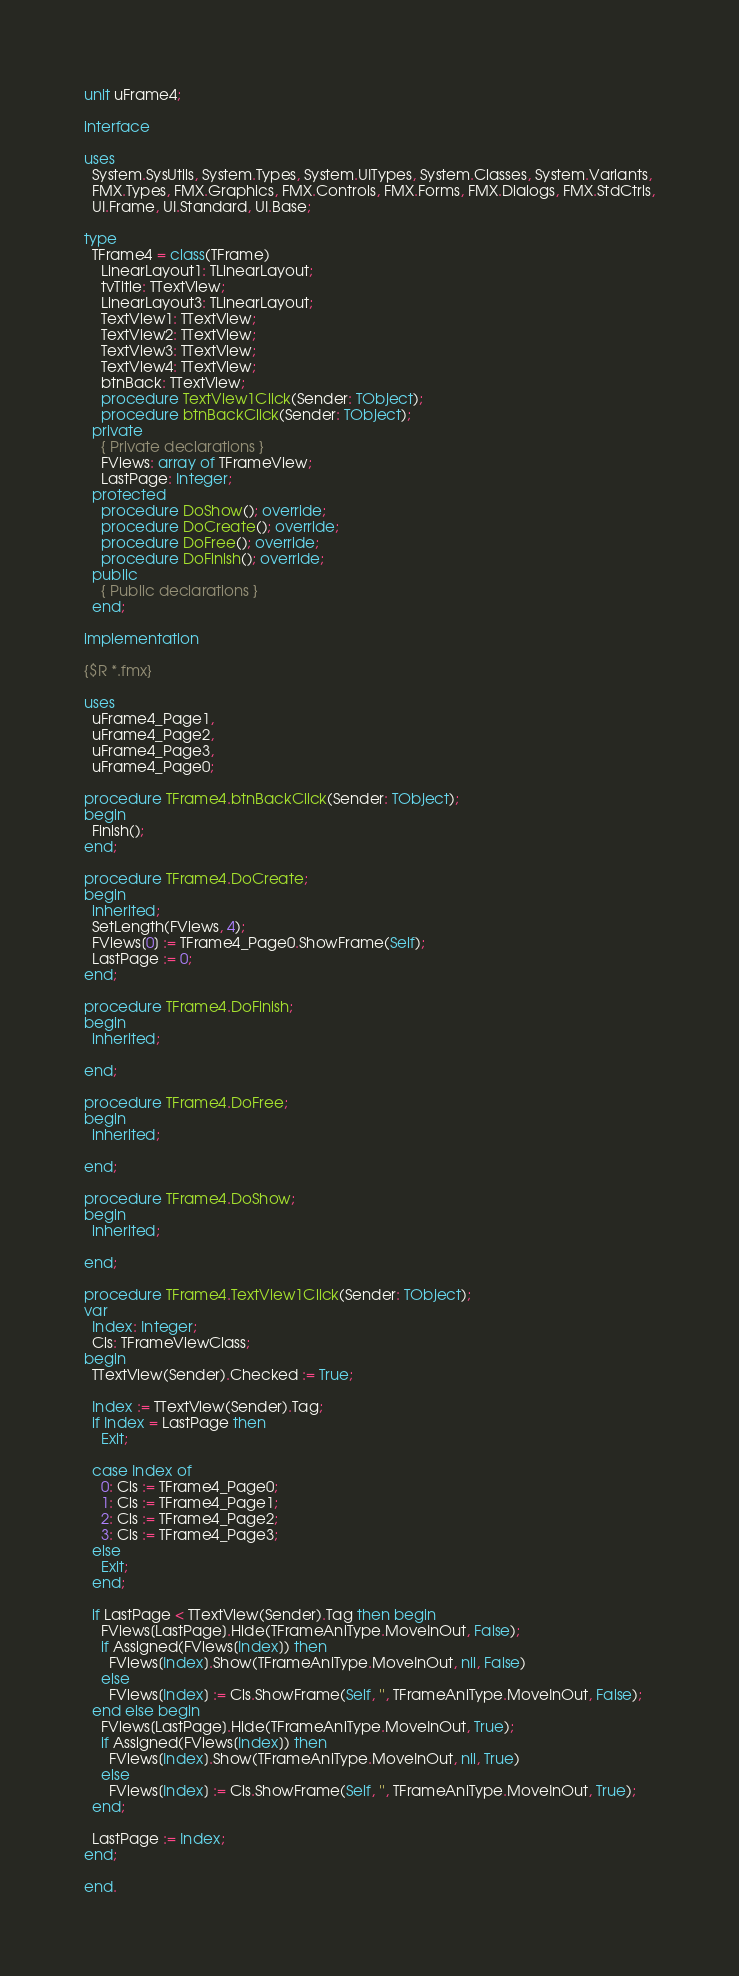Convert code to text. <code><loc_0><loc_0><loc_500><loc_500><_Pascal_>unit uFrame4;

interface

uses
  System.SysUtils, System.Types, System.UITypes, System.Classes, System.Variants,
  FMX.Types, FMX.Graphics, FMX.Controls, FMX.Forms, FMX.Dialogs, FMX.StdCtrls,
  UI.Frame, UI.Standard, UI.Base;

type
  TFrame4 = class(TFrame)
    LinearLayout1: TLinearLayout;
    tvTitle: TTextView;
    LinearLayout3: TLinearLayout;
    TextView1: TTextView;
    TextView2: TTextView;
    TextView3: TTextView;
    TextView4: TTextView;
    btnBack: TTextView;
    procedure TextView1Click(Sender: TObject);
    procedure btnBackClick(Sender: TObject);
  private
    { Private declarations }
    FViews: array of TFrameView;
    LastPage: Integer;
  protected
    procedure DoShow(); override;
    procedure DoCreate(); override;
    procedure DoFree(); override;
    procedure DoFinish(); override;
  public
    { Public declarations }
  end;

implementation

{$R *.fmx}

uses
  uFrame4_Page1,
  uFrame4_Page2,
  uFrame4_Page3,
  uFrame4_Page0;

procedure TFrame4.btnBackClick(Sender: TObject);
begin
  Finish();
end;

procedure TFrame4.DoCreate;
begin
  inherited;
  SetLength(FViews, 4);
  FViews[0] := TFrame4_Page0.ShowFrame(Self);
  LastPage := 0;
end;

procedure TFrame4.DoFinish;
begin
  inherited;

end;

procedure TFrame4.DoFree;
begin
  inherited;

end;

procedure TFrame4.DoShow;
begin
  inherited;

end;

procedure TFrame4.TextView1Click(Sender: TObject);
var
  Index: Integer;
  Cls: TFrameViewClass;
begin
  TTextView(Sender).Checked := True;

  Index := TTextView(Sender).Tag;
  if Index = LastPage then
    Exit;

  case Index of
    0: Cls := TFrame4_Page0;
    1: Cls := TFrame4_Page1;
    2: Cls := TFrame4_Page2;
    3: Cls := TFrame4_Page3;
  else
    Exit;
  end;

  if LastPage < TTextView(Sender).Tag then begin
    FViews[LastPage].Hide(TFrameAniType.MoveInOut, False);
    if Assigned(FViews[Index]) then
      FViews[Index].Show(TFrameAniType.MoveInOut, nil, False)
    else
      FViews[Index] := Cls.ShowFrame(Self, '', TFrameAniType.MoveInOut, False);
  end else begin
    FViews[LastPage].Hide(TFrameAniType.MoveInOut, True);
    if Assigned(FViews[Index]) then
      FViews[Index].Show(TFrameAniType.MoveInOut, nil, True)
    else
      FViews[Index] := Cls.ShowFrame(Self, '', TFrameAniType.MoveInOut, True);
  end;

  LastPage := Index;
end;

end.
</code> 